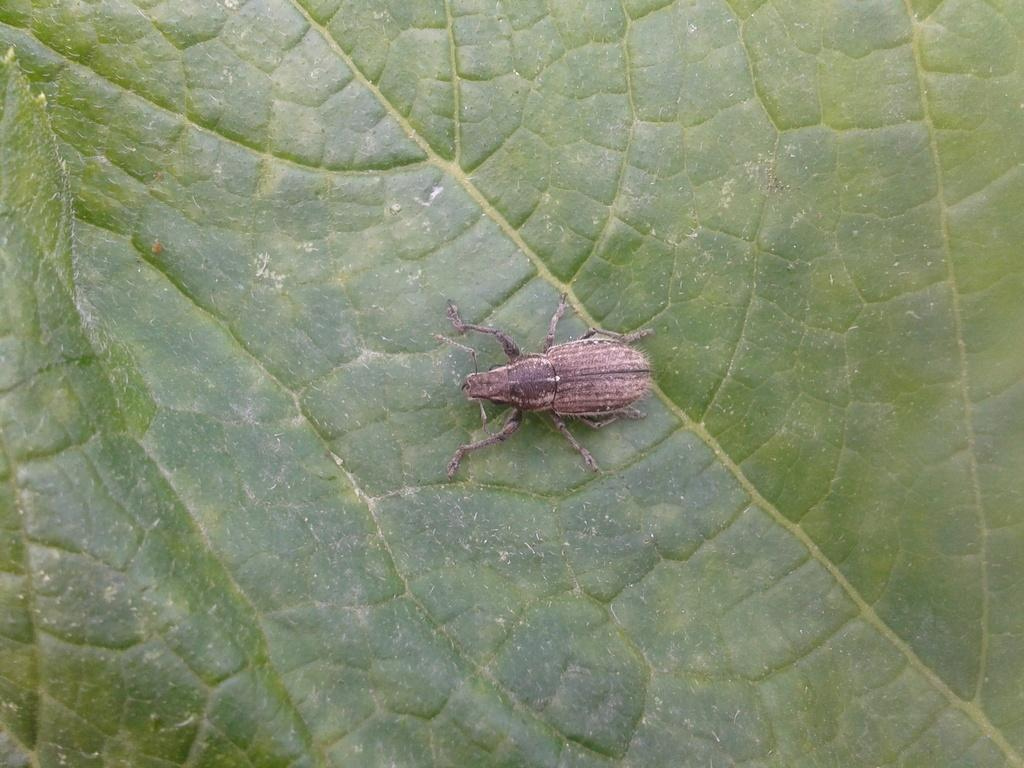What is present on the leaf in the image? There is an insect on the leaf in the image. What can be said about the color of the insect? The insect is brown in color. How many dogs are visible in the image? There are no dogs present in the image; it features an insect on a leaf. What type of map can be seen in the image? There is no map present in the image; it features an insect on a leaf. 